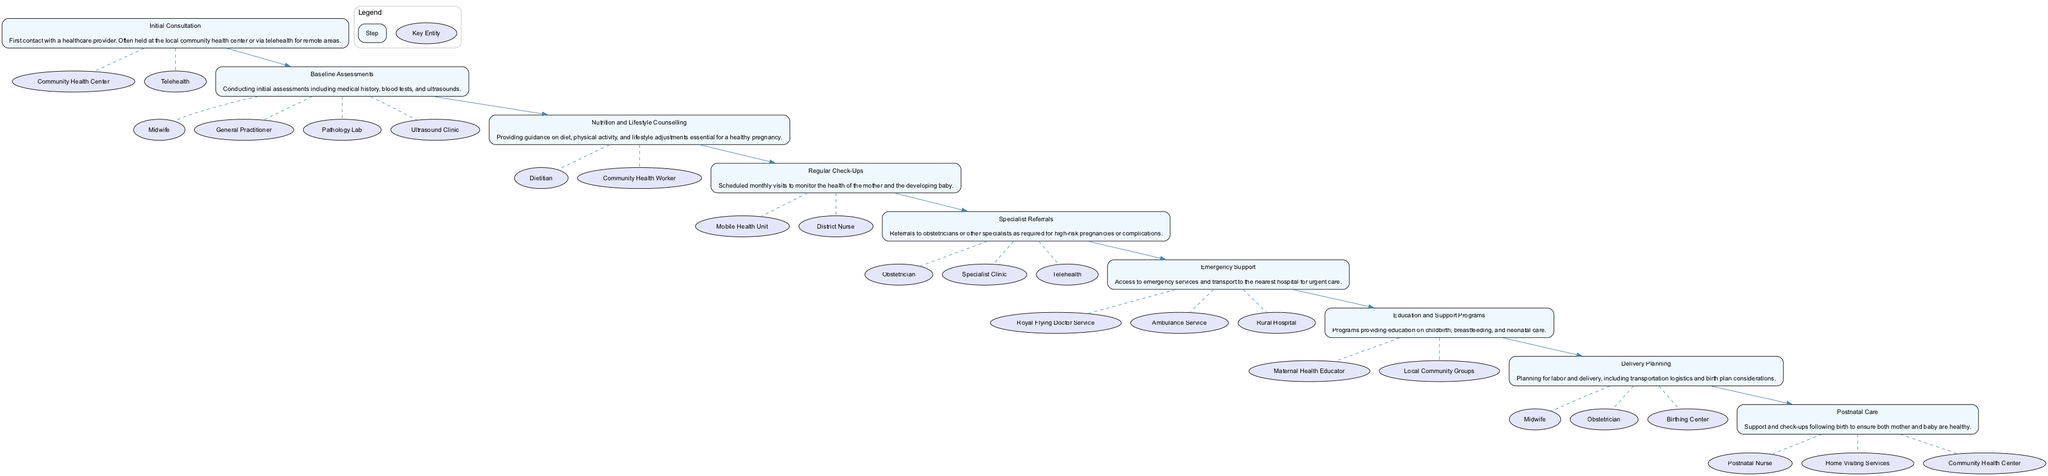What is the first step in the Prenatal Care Pathway? The first step listed in the diagram is "Initial Consultation." This is typically the starting point for prenatal care where the healthcare provider is contacted.
Answer: Initial Consultation How many key entities are associated with the "Regular Check-Ups" step? The "Regular Check-Ups" step lists two key entities: "Mobile Health Unit" and "District Nurse." Therefore, the number of entities linked to this step is two.
Answer: 2 What type of support is provided during the "Emergency Support" step? The "Emergency Support" step focuses on immediate access to emergency services, including transport to hospitals for urgent care needs. Key entities like "Royal Flying Doctor Service" are involved in this support.
Answer: Access to emergency services Which step includes specialist referrals? The "Specialist Referrals" step is specifically noted for making referrals to obstetricians and other specialists as required for high-risk pregnancies or complications.
Answer: Specialist Referrals What is the purpose of the "Education and Support Programs" step? This step is designed to provide education about childbirth, breastfeeding, and neonatal care, aiming to support new parents in the community effectively.
Answer: Education on childbirth and neonatal care How does "Delivery Planning" relate to "Postnatal Care"? "Delivery Planning" precedes "Postnatal Care" in the pathway, indicating a sequential process where planning for labor and delivery leads into the follow-up care provided after birth.
Answer: Sequential process Which entity is involved in the "Baseline Assessments" step? The "Baseline Assessments" step includes multiple entities, among which "Midwife" is a significant provider of care in conducting initial assessments such as medical history and blood tests.
Answer: Midwife What method is used for initial consultations in remote areas? In remote areas, initial consultations may occur via "Telehealth," enabling healthcare access without the need for physical travel to a health facility.
Answer: Telehealth What type of check-ups are scheduled during pregnancy? The type of check-ups referred to in the diagram during pregnancy are "Regular Check-Ups," which are scheduled monthly visits aimed at monitoring maternal and fetal health.
Answer: Regular Check-Ups 